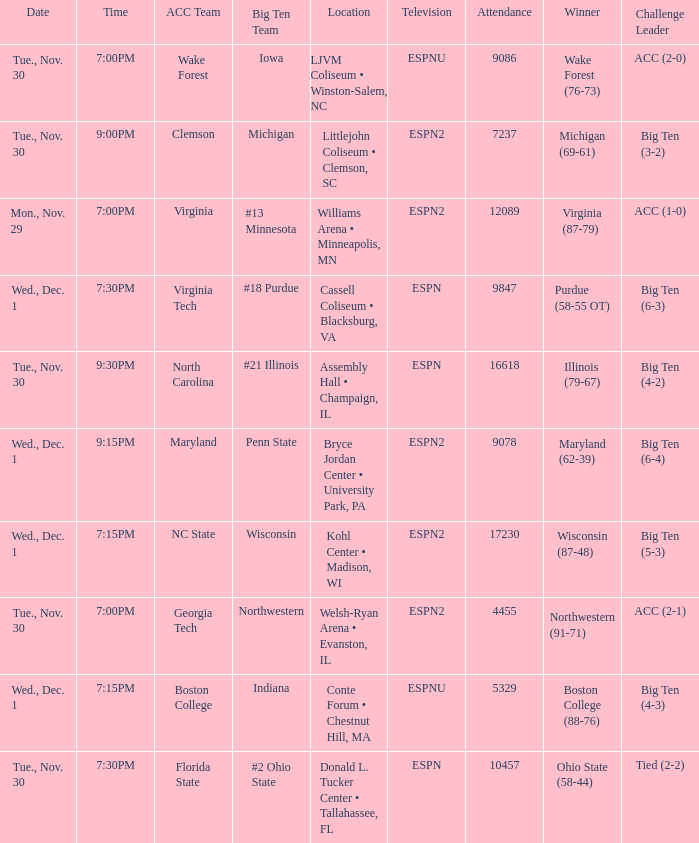Can you give me this table as a dict? {'header': ['Date', 'Time', 'ACC Team', 'Big Ten Team', 'Location', 'Television', 'Attendance', 'Winner', 'Challenge Leader'], 'rows': [['Tue., Nov. 30', '7:00PM', 'Wake Forest', 'Iowa', 'LJVM Coliseum • Winston-Salem, NC', 'ESPNU', '9086', 'Wake Forest (76-73)', 'ACC (2-0)'], ['Tue., Nov. 30', '9:00PM', 'Clemson', 'Michigan', 'Littlejohn Coliseum • Clemson, SC', 'ESPN2', '7237', 'Michigan (69-61)', 'Big Ten (3-2)'], ['Mon., Nov. 29', '7:00PM', 'Virginia', '#13 Minnesota', 'Williams Arena • Minneapolis, MN', 'ESPN2', '12089', 'Virginia (87-79)', 'ACC (1-0)'], ['Wed., Dec. 1', '7:30PM', 'Virginia Tech', '#18 Purdue', 'Cassell Coliseum • Blacksburg, VA', 'ESPN', '9847', 'Purdue (58-55 OT)', 'Big Ten (6-3)'], ['Tue., Nov. 30', '9:30PM', 'North Carolina', '#21 Illinois', 'Assembly Hall • Champaign, IL', 'ESPN', '16618', 'Illinois (79-67)', 'Big Ten (4-2)'], ['Wed., Dec. 1', '9:15PM', 'Maryland', 'Penn State', 'Bryce Jordan Center • University Park, PA', 'ESPN2', '9078', 'Maryland (62-39)', 'Big Ten (6-4)'], ['Wed., Dec. 1', '7:15PM', 'NC State', 'Wisconsin', 'Kohl Center • Madison, WI', 'ESPN2', '17230', 'Wisconsin (87-48)', 'Big Ten (5-3)'], ['Tue., Nov. 30', '7:00PM', 'Georgia Tech', 'Northwestern', 'Welsh-Ryan Arena • Evanston, IL', 'ESPN2', '4455', 'Northwestern (91-71)', 'ACC (2-1)'], ['Wed., Dec. 1', '7:15PM', 'Boston College', 'Indiana', 'Conte Forum • Chestnut Hill, MA', 'ESPNU', '5329', 'Boston College (88-76)', 'Big Ten (4-3)'], ['Tue., Nov. 30', '7:30PM', 'Florida State', '#2 Ohio State', 'Donald L. Tucker Center • Tallahassee, FL', 'ESPN', '10457', 'Ohio State (58-44)', 'Tied (2-2)']]} Where did the games that had Wisconsin as big ten team take place? Kohl Center • Madison, WI. 